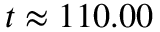Convert formula to latex. <formula><loc_0><loc_0><loc_500><loc_500>t \approx 1 1 0 . 0 0</formula> 